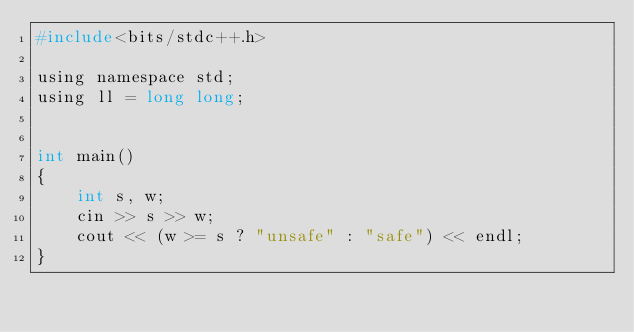Convert code to text. <code><loc_0><loc_0><loc_500><loc_500><_C_>#include<bits/stdc++.h>

using namespace std;
using ll = long long;


int main()
{
    int s, w;
    cin >> s >> w;
    cout << (w >= s ? "unsafe" : "safe") << endl;
}</code> 